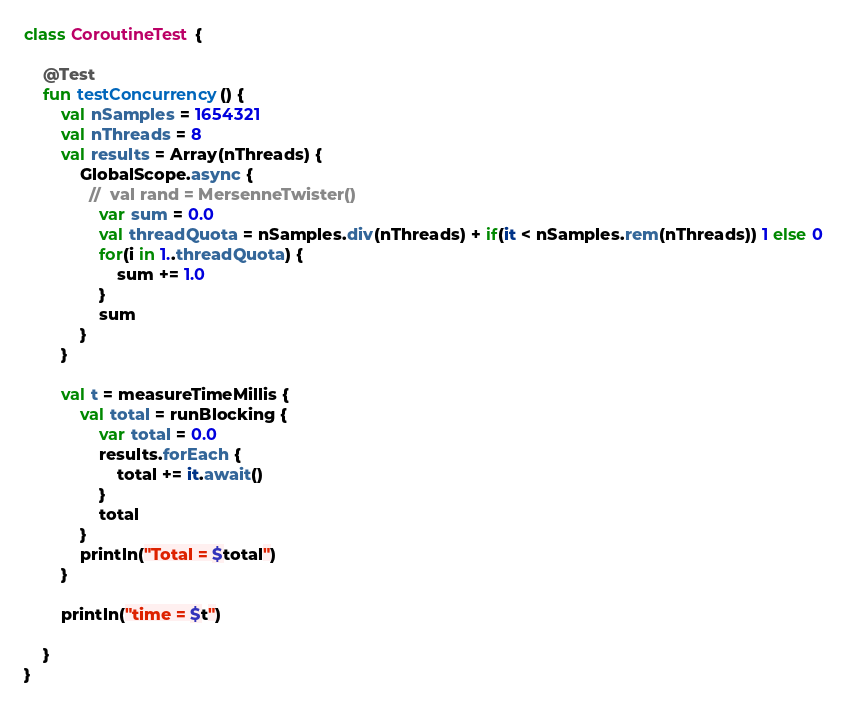<code> <loc_0><loc_0><loc_500><loc_500><_Kotlin_>class CoroutineTest {

    @Test
    fun testConcurrency() {
        val nSamples = 1654321
        val nThreads = 8
        val results = Array(nThreads) {
            GlobalScope.async {
              //  val rand = MersenneTwister()
                var sum = 0.0
                val threadQuota = nSamples.div(nThreads) + if(it < nSamples.rem(nThreads)) 1 else 0
                for(i in 1..threadQuota) {
                    sum += 1.0
                }
                sum
            }
        }

        val t = measureTimeMillis {
            val total = runBlocking {
                var total = 0.0
                results.forEach {
                    total += it.await()
                }
                total
            }
            println("Total = $total")
        }

        println("time = $t")

    }
}</code> 